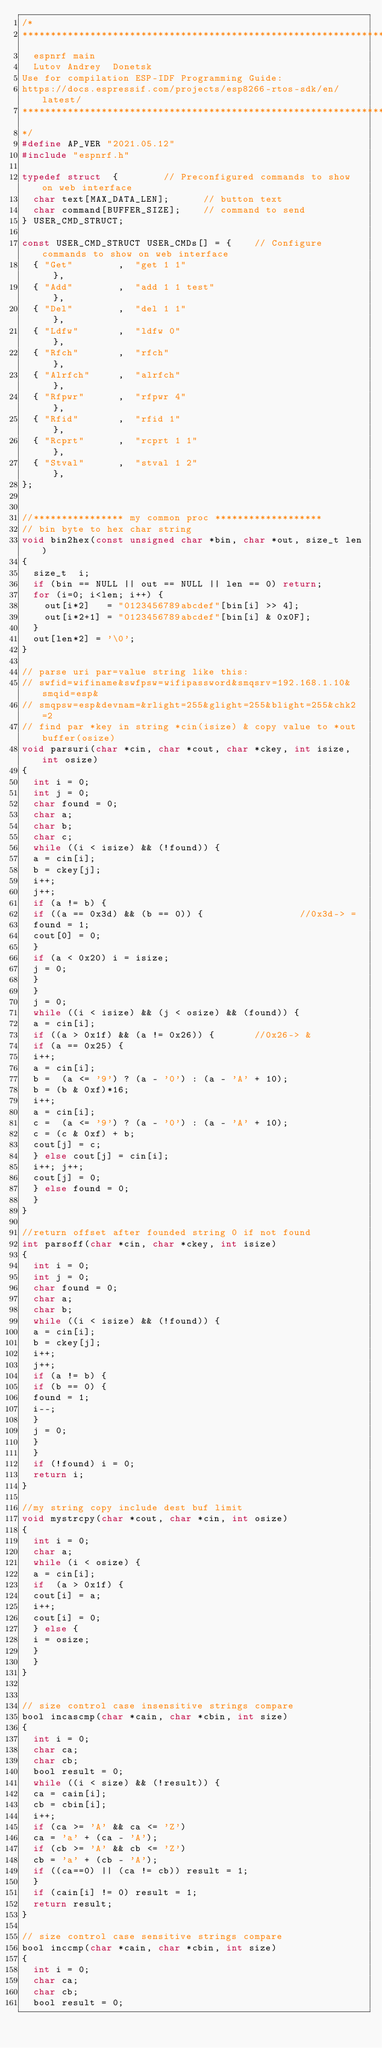Convert code to text. <code><loc_0><loc_0><loc_500><loc_500><_C_>/* 
****************************************************************
	espnrf main
	Lutov Andrey  Donetsk
Use for compilation ESP-IDF Programming Guide:
https://docs.espressif.com/projects/esp8266-rtos-sdk/en/latest/
****************************************************************
*/
#define AP_VER "2021.05.12"
#include "espnrf.h"

typedef struct  {        // Preconfigured commands to show on web interface
  char text[MAX_DATA_LEN];      // button text
  char command[BUFFER_SIZE];    // command to send
} USER_CMD_STRUCT;

const USER_CMD_STRUCT USER_CMDs[] = {    // Configure commands to show on web interface
  { "Get"        ,  "get 1 1"                               },
  { "Add"        ,  "add 1 1 test"                          },
  { "Del"        ,  "del 1 1"                               },
  { "Ldfw"       ,  "ldfw 0"                                },
  { "Rfch"       ,  "rfch"                                  },
  { "Alrfch"     ,  "alrfch"                                },
  { "Rfpwr"      ,  "rfpwr 4"                               },
  { "Rfid"       ,  "rfid 1"                                },
  { "Rcprt"      ,  "rcprt 1 1"                             },
  { "Stval"      ,  "stval 1 2"                             },
};


//**************** my common proc *******************
// bin byte to hex char string
void bin2hex(const unsigned char *bin, char *out, size_t len)
{
	size_t  i;
	if (bin == NULL || out == NULL || len == 0) return;
	for (i=0; i<len; i++) {
		out[i*2]   = "0123456789abcdef"[bin[i] >> 4];
		out[i*2+1] = "0123456789abcdef"[bin[i] & 0x0F];
	}
	out[len*2] = '\0';
}

// parse uri par=value string like this:
// swfid=wifiname&swfpsw=wifipassword&smqsrv=192.168.1.10&smqid=esp&
// smqpsw=esp&devnam=&rlight=255&glight=255&blight=255&chk2=2
// find par *key in string *cin(isize) & copy value to *out buffer(osize) 
void parsuri(char *cin, char *cout, char *ckey, int isize, int osize)
{
	int i = 0;
	int j = 0;
	char found = 0;
	char a;
	char b;
	char c;
	while ((i < isize) && (!found)) {
	a = cin[i];
	b = ckey[j];
	i++;
	j++;
	if (a != b) {
	if ((a == 0x3d) && (b == 0)) {                 //0x3d-> =
	found = 1;
	cout[0] = 0;
	}
	if (a < 0x20) i = isize;
	j = 0;
	}
	}	
	j = 0;
	while ((i < isize) && (j < osize) && (found)) {
	a = cin[i];
	if ((a > 0x1f) && (a != 0x26)) {       //0x26-> &
	if (a == 0x25) {
	i++;
	a = cin[i];
	b =  (a <= '9') ? (a - '0') : (a - 'A' + 10);
	b = (b & 0xf)*16;
	i++;
	a = cin[i];
	c =  (a <= '9') ? (a - '0') : (a - 'A' + 10);
	c = (c & 0xf) + b;
	cout[j] = c;
	} else cout[j] = cin[i];
	i++; j++;
	cout[j] = 0;
	} else found = 0;
	}
}

//return offset after founded string 0 if not found
int parsoff(char *cin, char *ckey, int isize)
{
	int i = 0;
	int j = 0;
	char found = 0;
	char a;
	char b;
	while ((i < isize) && (!found)) {
	a = cin[i];
	b = ckey[j];
	i++;
	j++;
	if (a != b) {
	if (b == 0) {
	found = 1;
	i--;
	}
	j = 0;
	}
	}	
	if (!found) i = 0;
	return i;
}

//my string copy include dest buf limit
void mystrcpy(char *cout, char *cin, int osize)
{
	int i = 0;
	char a;
	while (i < osize) {
	a = cin[i];
	if  (a > 0x1f) {
	cout[i] = a;
	i++;
	cout[i] = 0;
	} else {
	i = osize;
	}		
	}
}


// size control case insensitive strings compare 
bool incascmp(char *cain, char *cbin, int size)
{
	int i = 0;
	char ca;
	char cb;
	bool result = 0;
	while ((i < size) && (!result)) {
	ca = cain[i];
	cb = cbin[i];
	i++;
	if (ca >= 'A' && ca <= 'Z')
	ca = 'a' + (ca - 'A');
	if (cb >= 'A' && cb <= 'Z')
	cb = 'a' + (cb - 'A');
	if ((ca==0) || (ca != cb)) result = 1;
	}
	if (cain[i] != 0) result = 1;
	return result;
}

// size control case sensitive strings compare 
bool inccmp(char *cain, char *cbin, int size)
{
	int i = 0;
	char ca;
	char cb;
	bool result = 0;</code> 